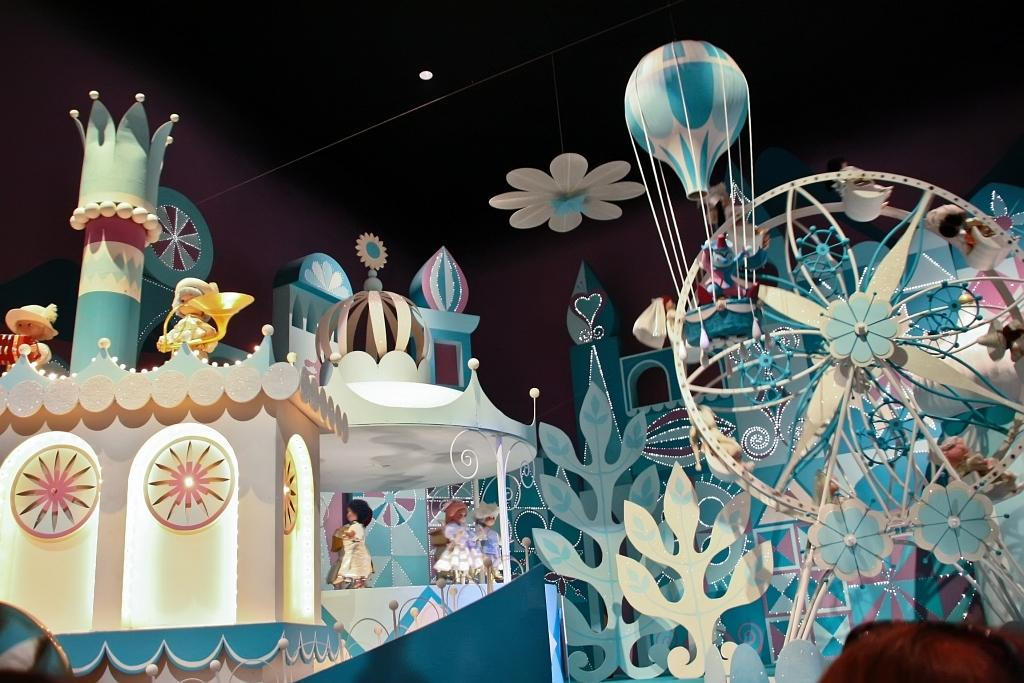What type of objects can be seen in the image? There are toys, depictions of rides, and a parachute in the image. Can you describe the rides depicted in the image? The image shows depictions of rides, but it does not provide specific details about them. What other objects are present in the image besides the toys, rides, and parachute? There are other objects in the image, but their specific nature is not mentioned in the provided facts. What type of plantation can be seen in the image? There is no plantation present in the image. What spot in the image is the most thrilling? The provided facts do not mention any specific spots or thrilling elements in the image. 